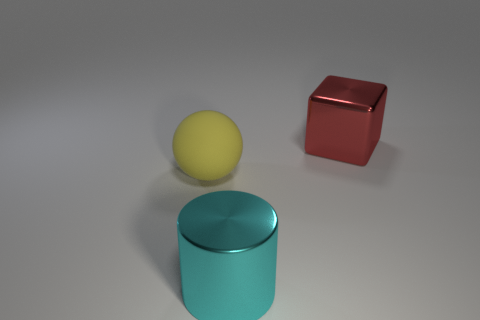Add 3 big rubber balls. How many objects exist? 6 Subtract all cylinders. How many objects are left? 2 Subtract all tiny cylinders. Subtract all cyan metallic cylinders. How many objects are left? 2 Add 2 metal cylinders. How many metal cylinders are left? 3 Add 2 red cylinders. How many red cylinders exist? 2 Subtract 0 blue cylinders. How many objects are left? 3 